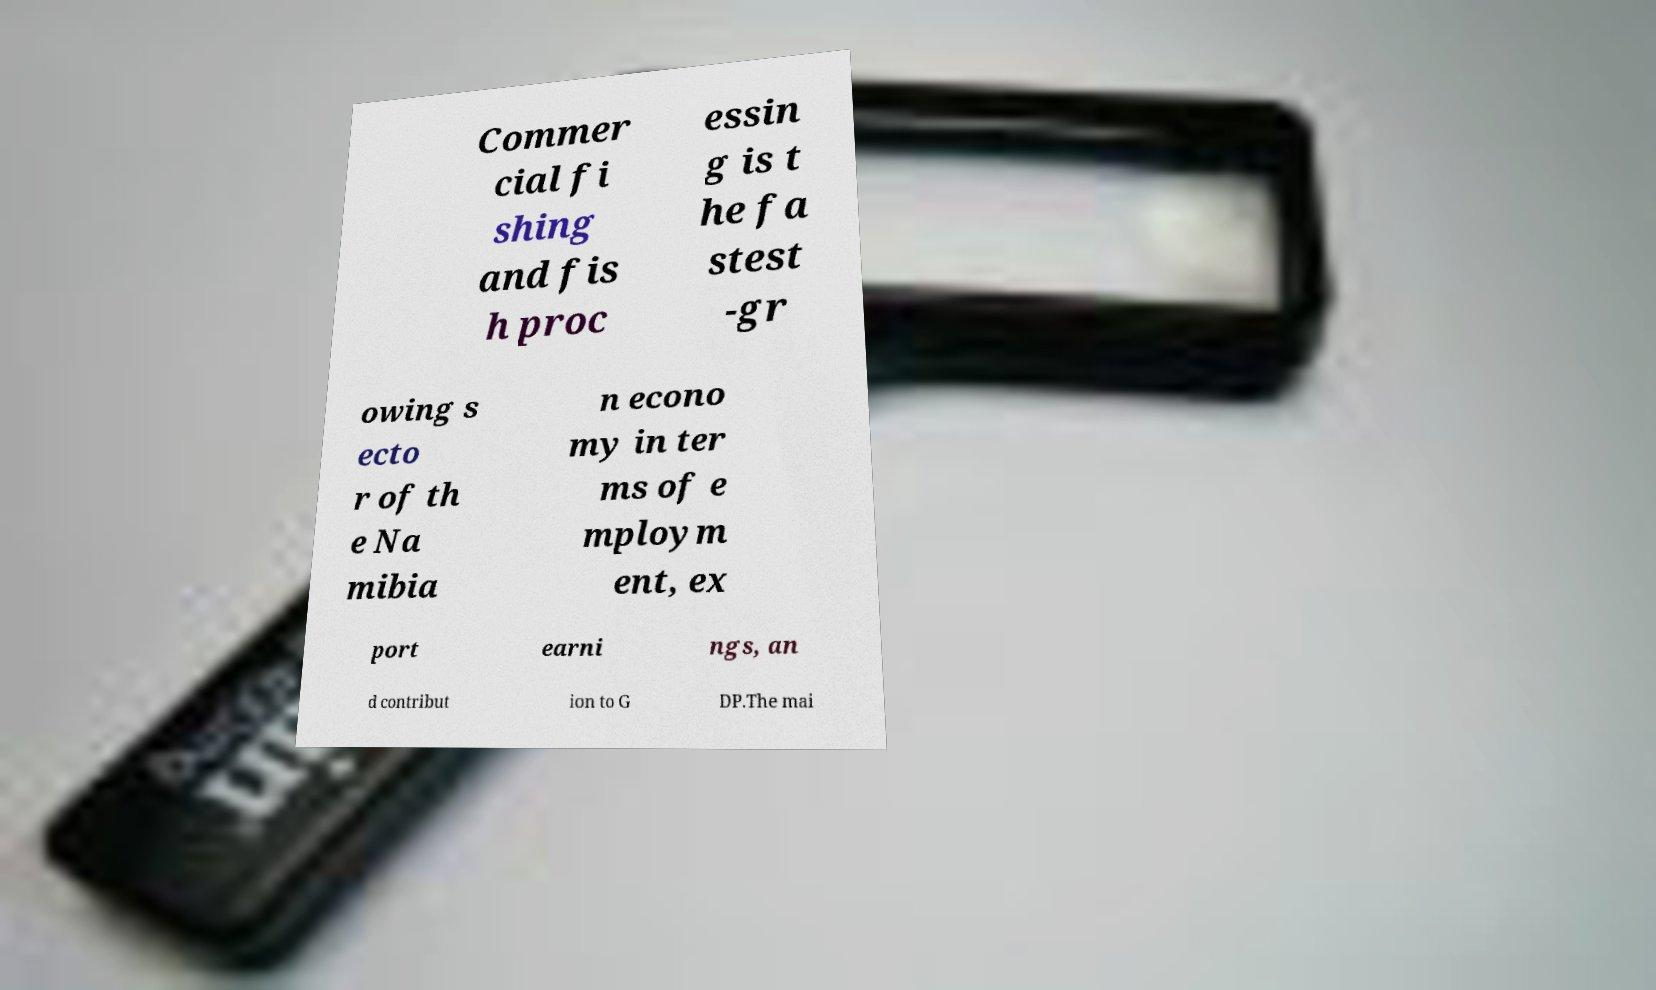There's text embedded in this image that I need extracted. Can you transcribe it verbatim? Commer cial fi shing and fis h proc essin g is t he fa stest -gr owing s ecto r of th e Na mibia n econo my in ter ms of e mploym ent, ex port earni ngs, an d contribut ion to G DP.The mai 